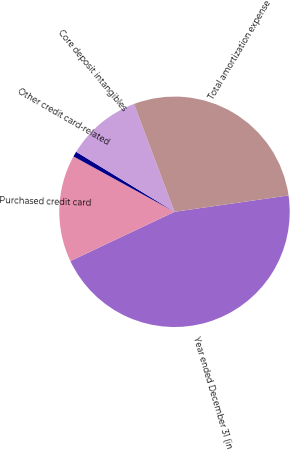Convert chart to OTSL. <chart><loc_0><loc_0><loc_500><loc_500><pie_chart><fcel>Year ended December 31 (in<fcel>Purchased credit card<fcel>Other credit card-related<fcel>Core deposit intangibles<fcel>Total amortization expense<nl><fcel>45.23%<fcel>15.01%<fcel>0.74%<fcel>10.56%<fcel>28.45%<nl></chart> 